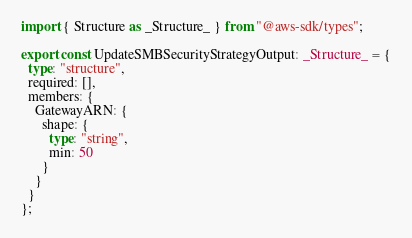Convert code to text. <code><loc_0><loc_0><loc_500><loc_500><_TypeScript_>import { Structure as _Structure_ } from "@aws-sdk/types";

export const UpdateSMBSecurityStrategyOutput: _Structure_ = {
  type: "structure",
  required: [],
  members: {
    GatewayARN: {
      shape: {
        type: "string",
        min: 50
      }
    }
  }
};
</code> 